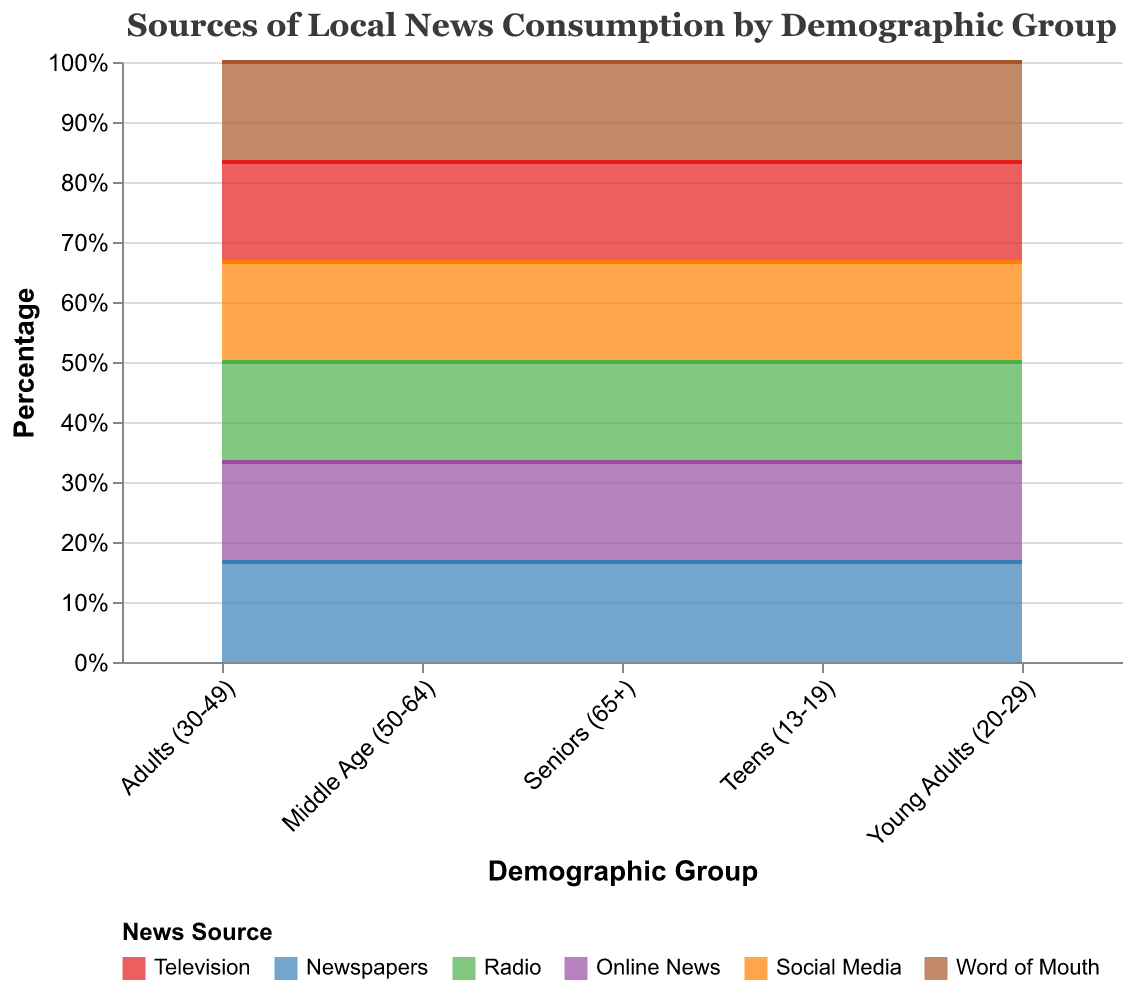What is the title of the chart? The title is located at the top of the chart. It gives a description of what the chart represents.
Answer: Sources of Local News Consumption by Demographic Group How many demographic groups are represented in the chart? The chart shows the categories on the x-axis, representing the demographic groups. Count the number of labels along this axis.
Answer: 5 Which news source has the highest percentage among teens? Look at the area corresponding to the "Teens (13-19)" group and identify the largest section.
Answer: Social Media What is the combined percentage of Online News and Social Media for Young Adults? Add the percentage of Online News (30%) and Social Media (25%) for the Young Adults group.
Answer: 55% How does the percentage of Television consumption compare between Adults (30-49) and Seniors (65+)? Compare the percentage values for Television consumption in both the Adults (30-49) and Seniors (65+) categories.
Answer: It is higher for Seniors Which demographic group has the lowest percentage for Word of Mouth? Look at the Word of Mouth sections across all demographic groups and find the smallest area.
Answer: Seniors (65+) What is the average percentage for Newspapers across all demographic groups? Add the percentages for Newspapers in all groups and divide by the number of groups (5). Calculation: (5+8+15+20+35)/5
Answer: 16.6% Identify the primary news source for Middle Age (50-64). Find the largest section in the "Middle Age (50-64)" category.
Answer: Television How much greater is the percentage of Social Media consumption in Teens (13-19) compared to Seniors (65+)? Subtract the percentage of Social Media consumption for Seniors (8%) from Teens (35%).
Answer: 27% Which two news sources have the closest percentages in the Young Adult (20-29) group? Compare the percentages of each news source in the Young Adult category to identify the closest values.
Answer: Word of Mouth and Newspapers 